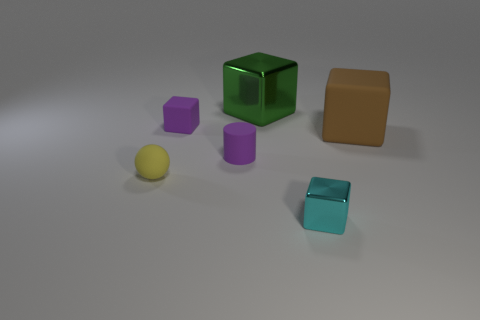Subtract 1 blocks. How many blocks are left? 3 Add 1 red rubber cylinders. How many objects exist? 7 Subtract all balls. How many objects are left? 5 Add 1 small red rubber cylinders. How many small red rubber cylinders exist? 1 Subtract 0 green cylinders. How many objects are left? 6 Subtract all small cyan shiny things. Subtract all green rubber spheres. How many objects are left? 5 Add 2 large brown blocks. How many large brown blocks are left? 3 